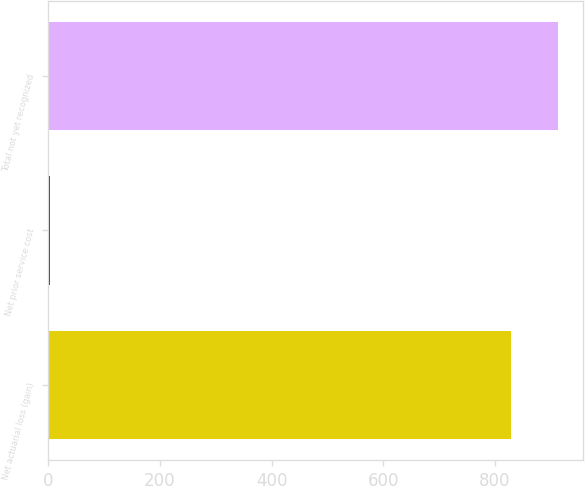Convert chart to OTSL. <chart><loc_0><loc_0><loc_500><loc_500><bar_chart><fcel>Net actuarial loss (gain)<fcel>Net prior service cost<fcel>Total not yet recognized<nl><fcel>828.9<fcel>3.4<fcel>911.79<nl></chart> 